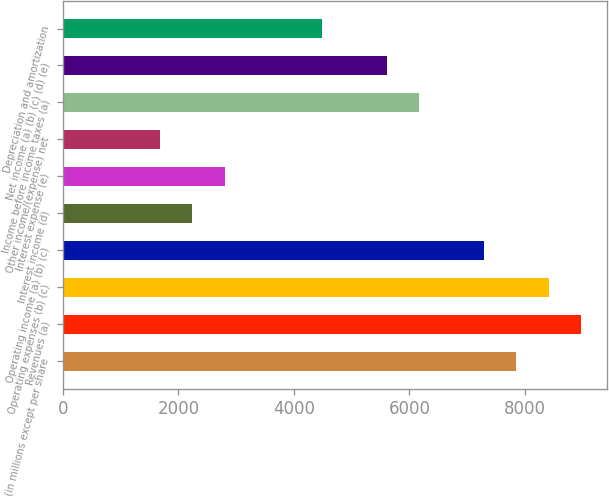Convert chart to OTSL. <chart><loc_0><loc_0><loc_500><loc_500><bar_chart><fcel>(in millions except per share<fcel>Revenues (a)<fcel>Operating expenses (b) (c)<fcel>Operating income (a) (b) (c)<fcel>Interest income (d)<fcel>Interest expense (e)<fcel>Other income/(expense) net<fcel>Income before income taxes (a)<fcel>Net income (a) (b) (c) (d) (e)<fcel>Depreciation and amortization<nl><fcel>7849.88<fcel>8971.22<fcel>8410.55<fcel>7289.21<fcel>2243.18<fcel>2803.85<fcel>1682.51<fcel>6167.87<fcel>5607.2<fcel>4485.86<nl></chart> 